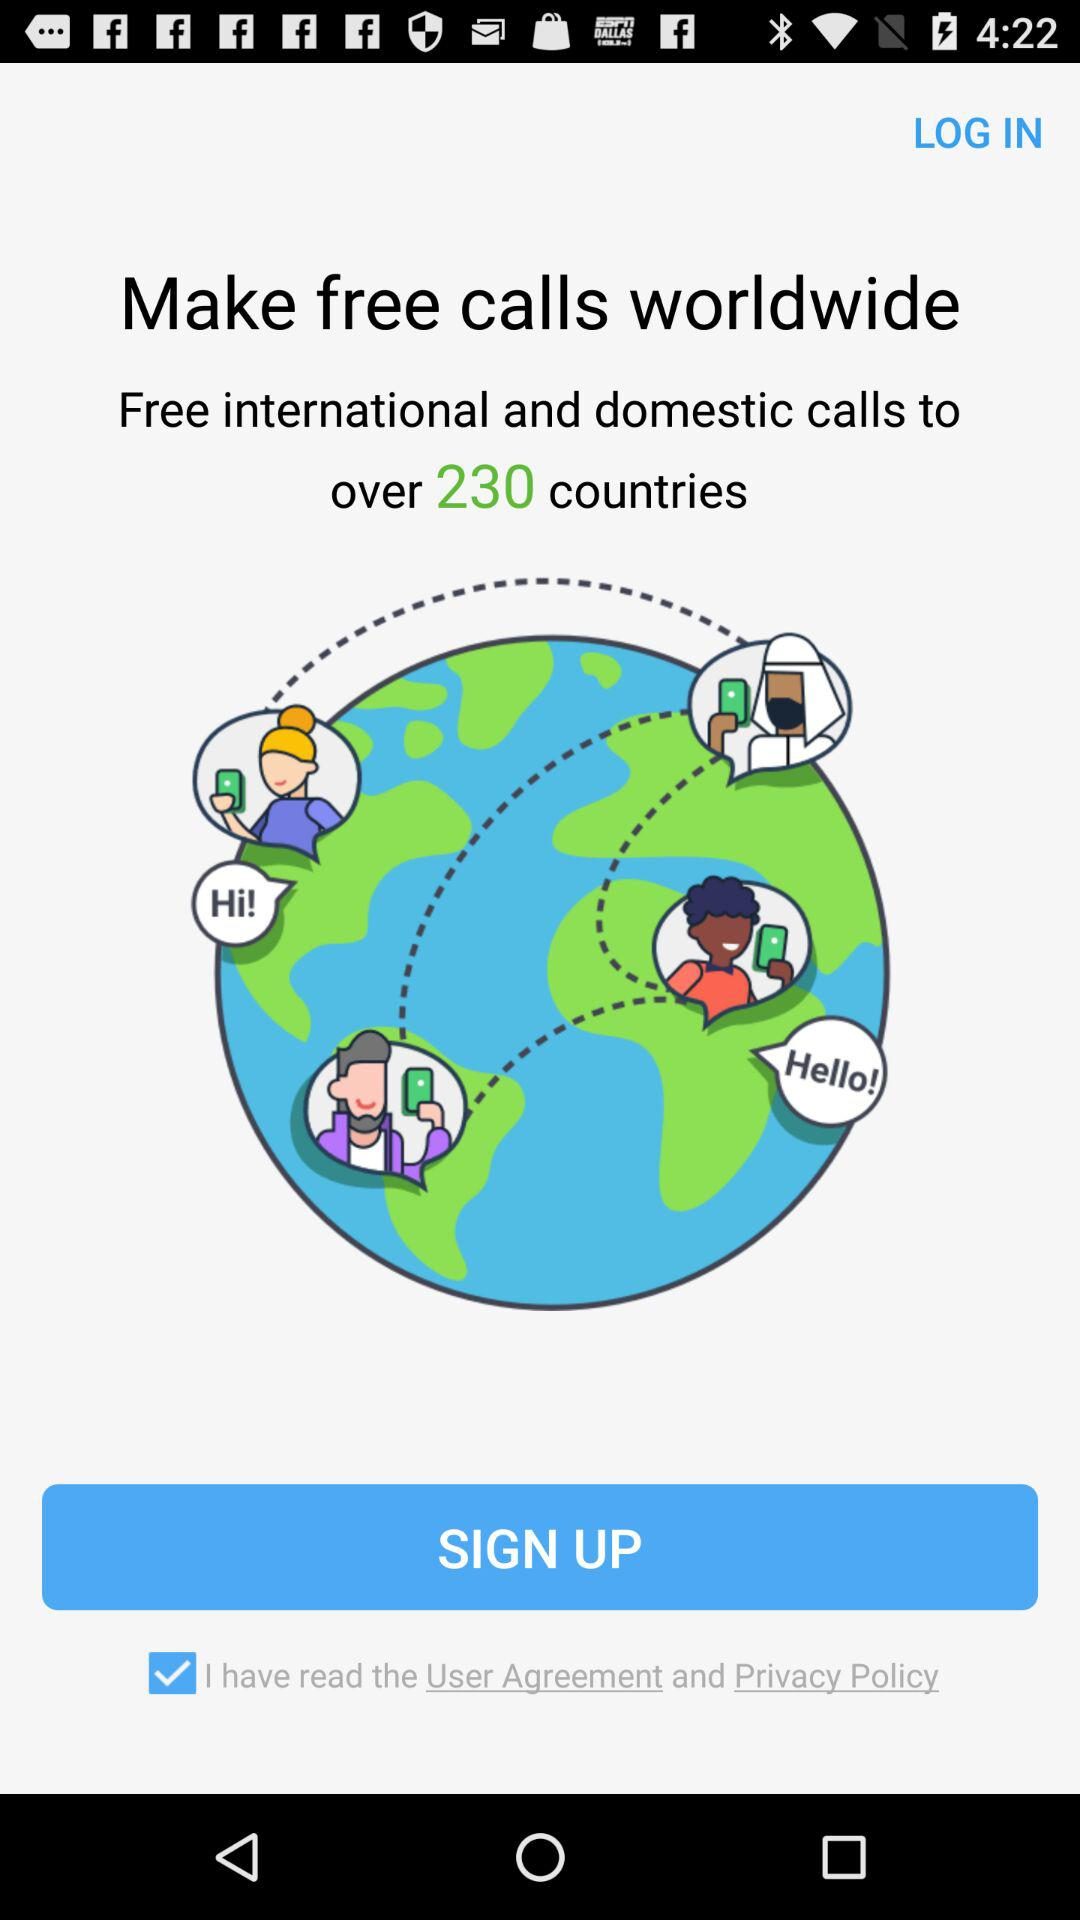How many countries have the facility of free international and domestic calls? The facility of free international and domestic calls is available to over 230 countries. 